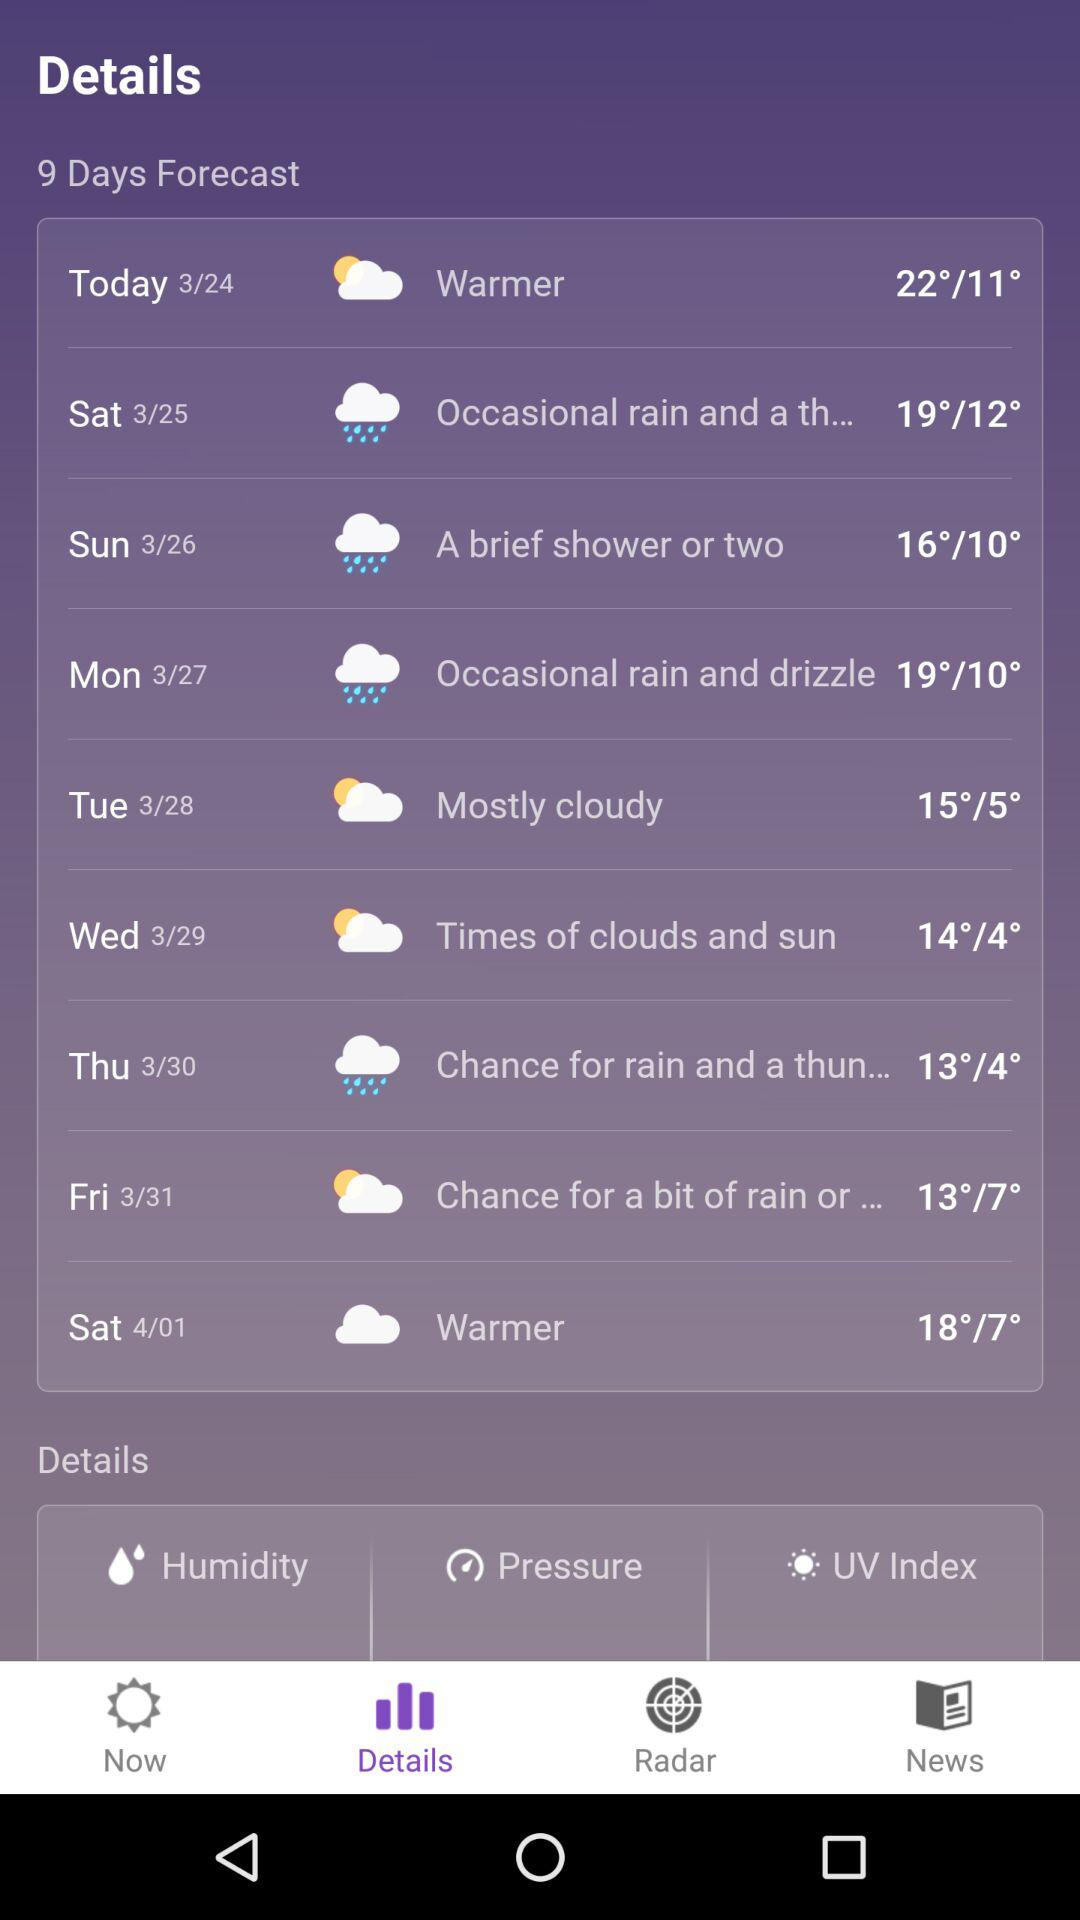Which tab is selected? The selected tab is "Details". 